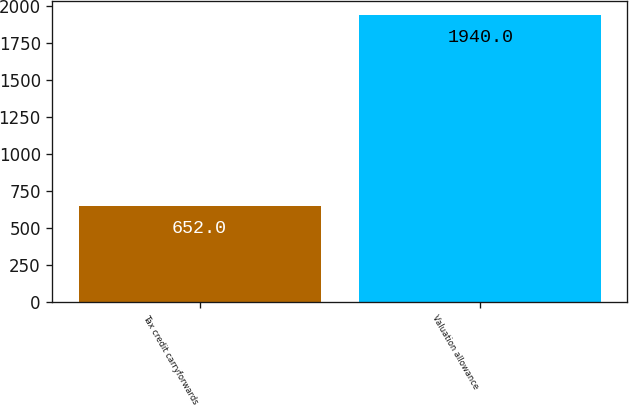<chart> <loc_0><loc_0><loc_500><loc_500><bar_chart><fcel>Tax credit carryforwards<fcel>Valuation allowance<nl><fcel>652<fcel>1940<nl></chart> 